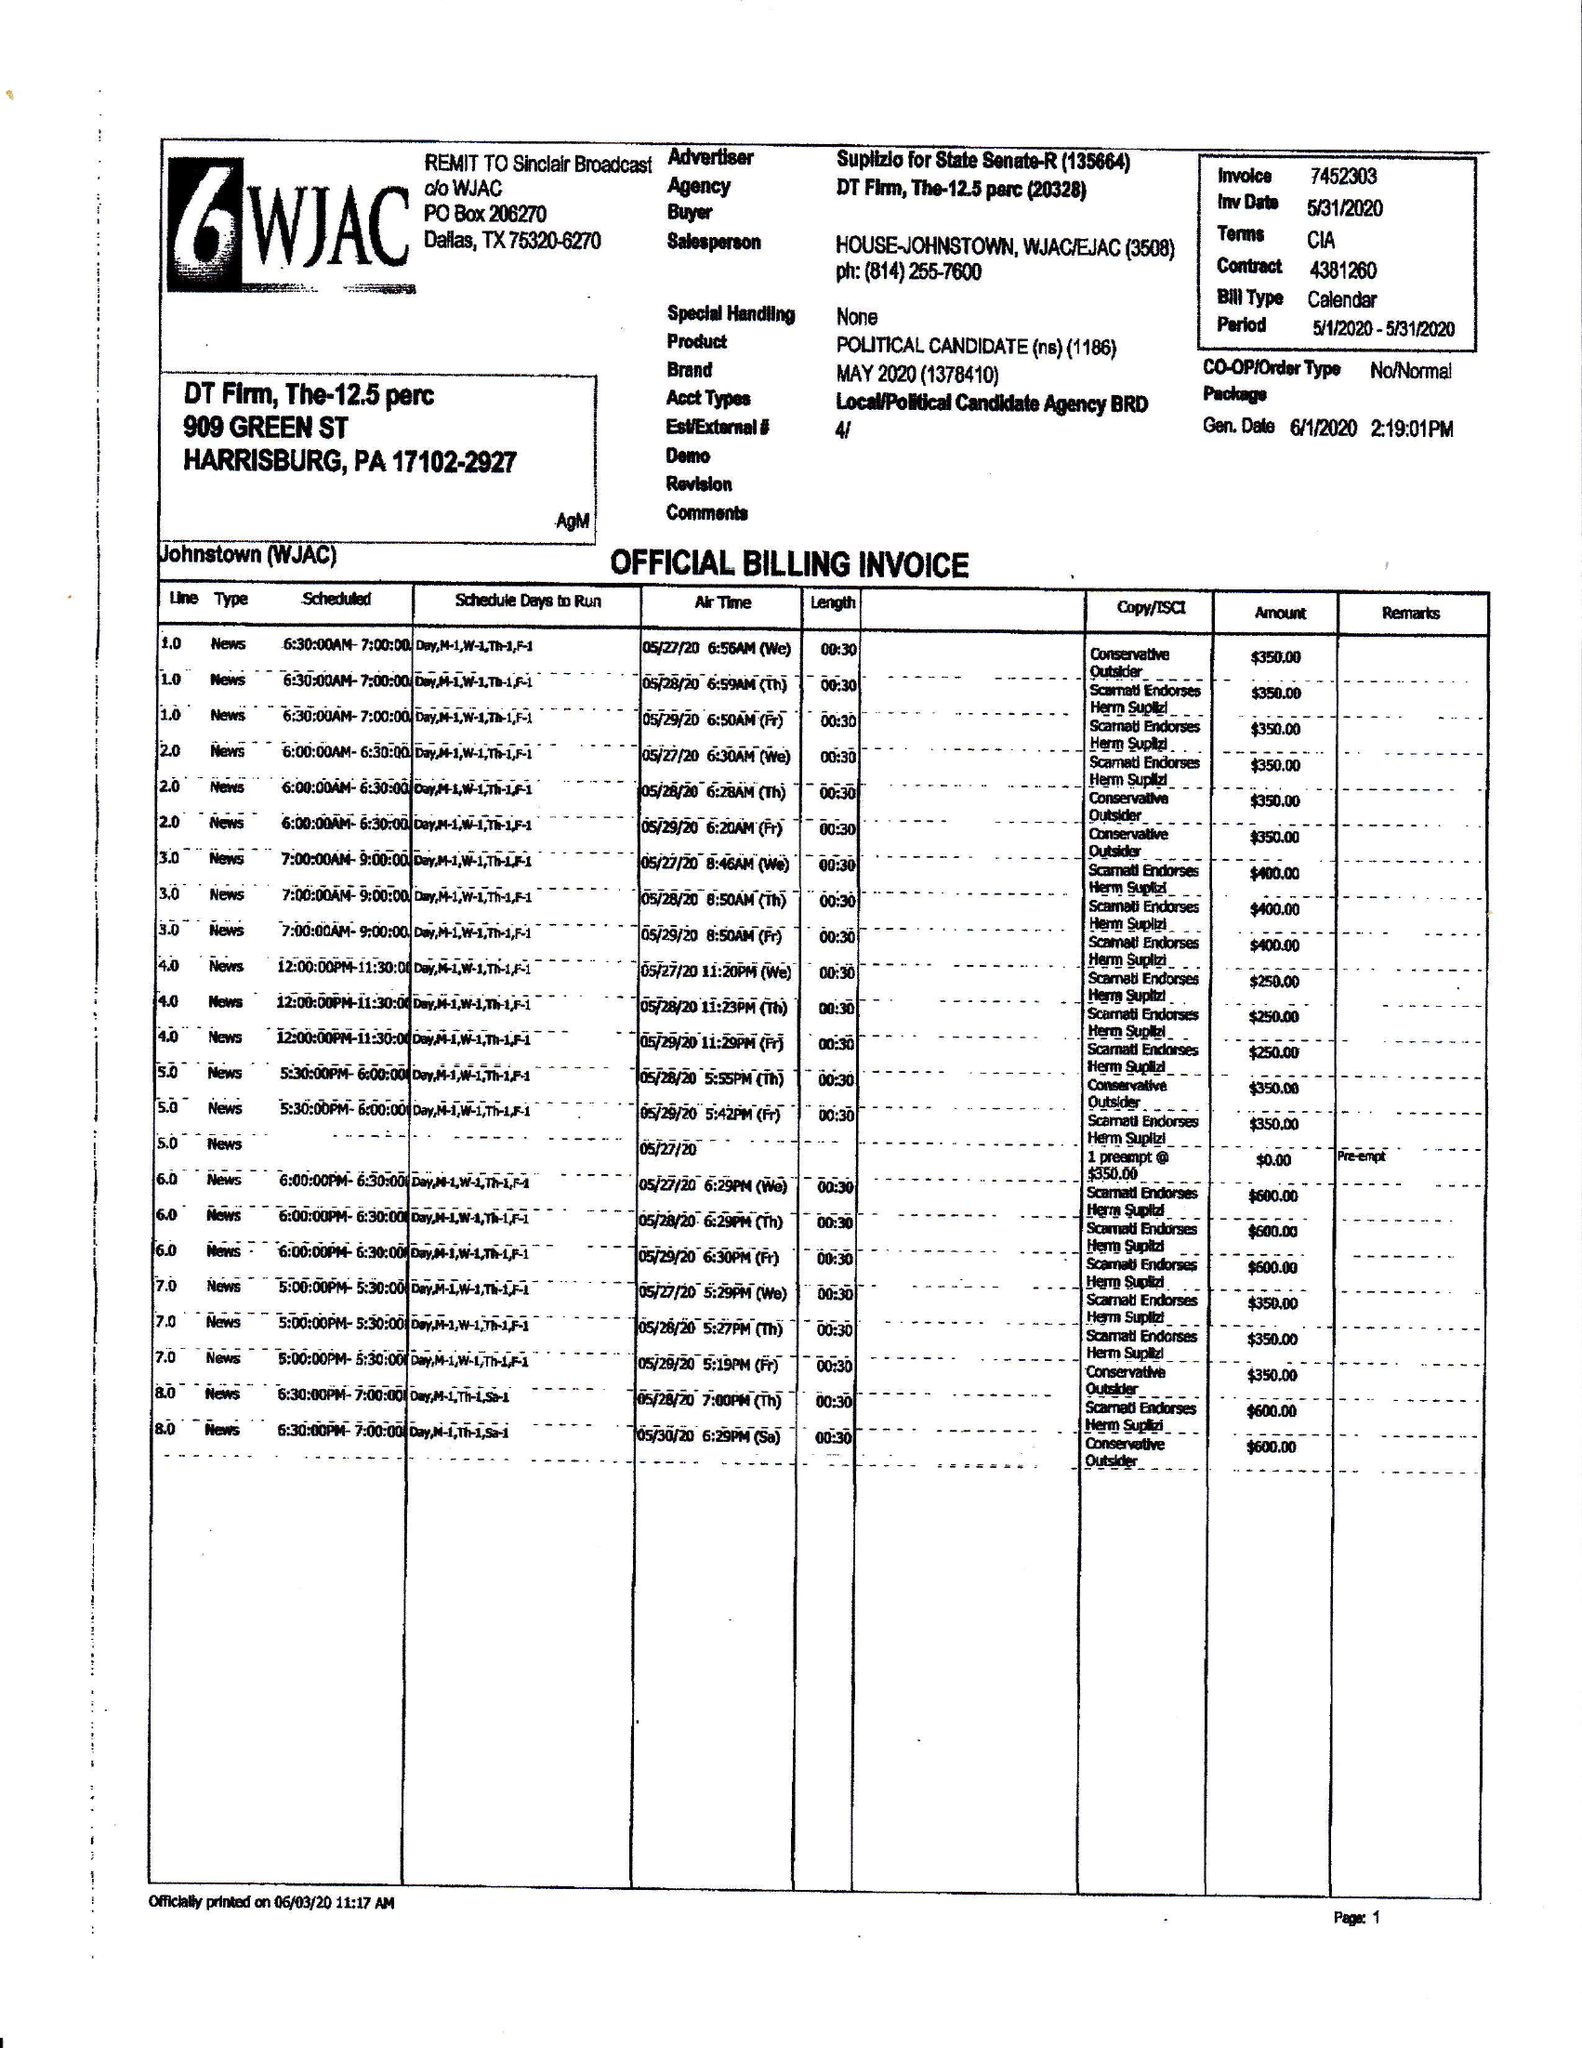What is the value for the advertiser?
Answer the question using a single word or phrase. SUPLIZLO FOR STATE SENATE 